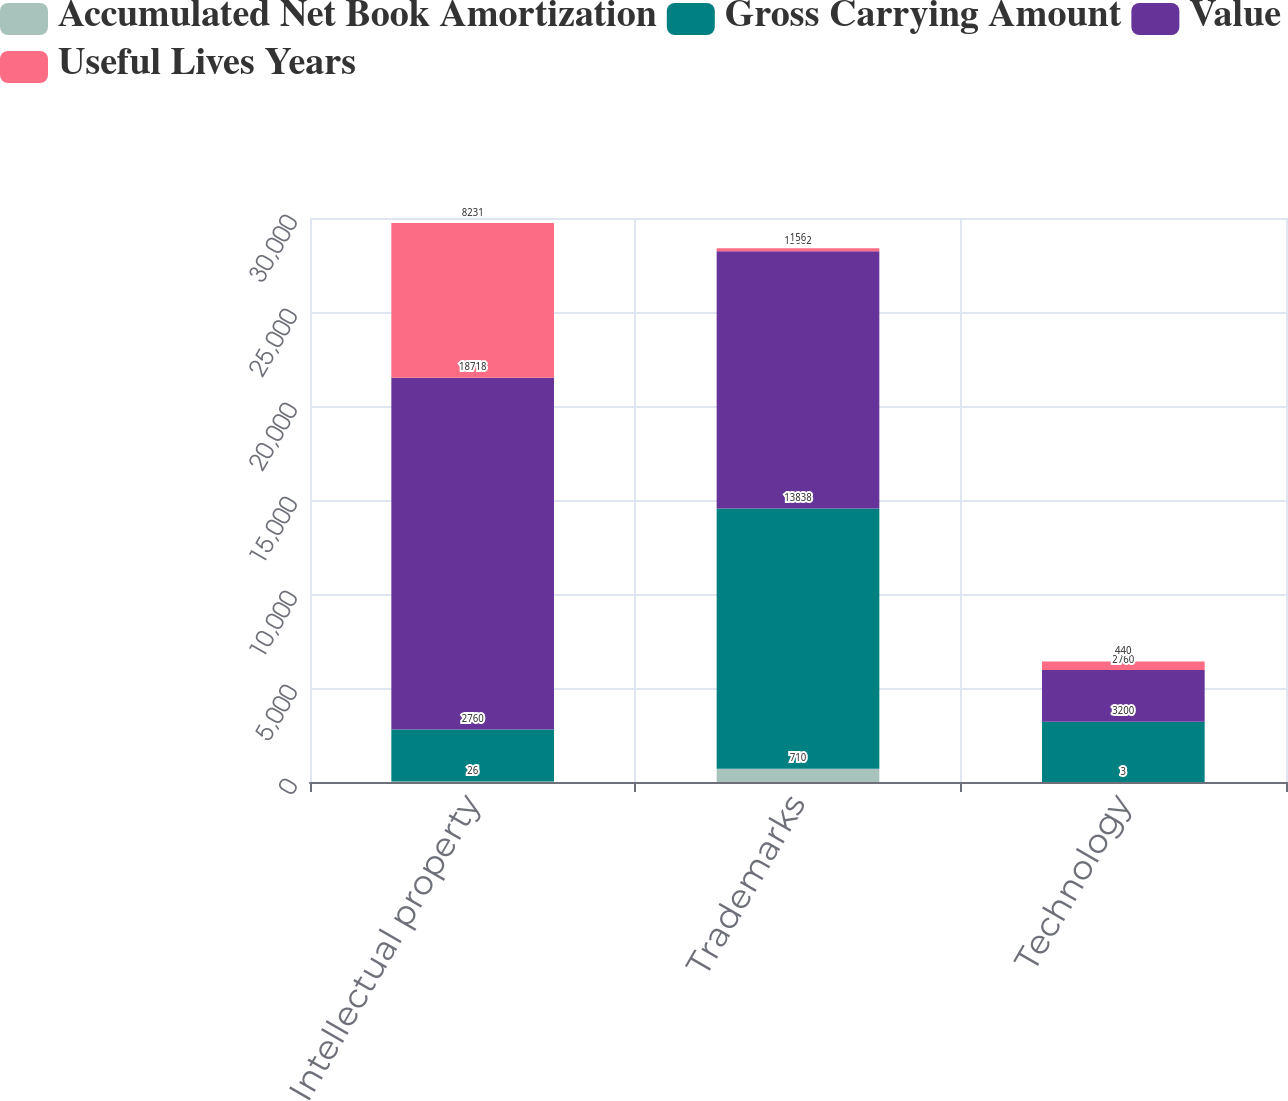<chart> <loc_0><loc_0><loc_500><loc_500><stacked_bar_chart><ecel><fcel>Intellectual property<fcel>Trademarks<fcel>Technology<nl><fcel>Accumulated Net Book Amortization<fcel>26<fcel>710<fcel>3<nl><fcel>Gross Carrying Amount<fcel>2760<fcel>13838<fcel>3200<nl><fcel>Value<fcel>18718<fcel>13682<fcel>2760<nl><fcel>Useful Lives Years<fcel>8231<fcel>156<fcel>440<nl></chart> 